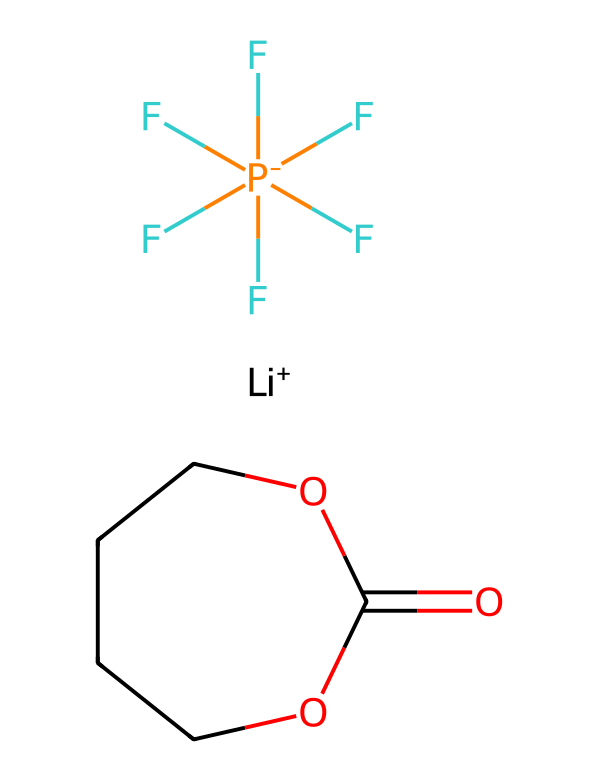What is the molecular formula of this compound? The compound consists of multiple atoms including carbon, oxygen, fluorine, and lithium. By counting the atoms in the provided SMILES representation, we find the molecular formula is C4H6F5LiO3.
Answer: C4H6F5LiO3 How many fluorine atoms are present? Looking at the fluorine section of the SMILES, there are five fluorine atoms depicted before the lithium ion.
Answer: 5 What functional groups are present? Analyzing the structure indicates that there are an ester (C1COC(=O)O) and a phosphate group (F[P-](F)(F)(F)(F)F) present in the chemical structure.
Answer: ester and phosphate What is the oxidation state of lithium in this compound? In the given SMILES, lithium is shown as a Li+ ion, indicating that its oxidation state is +1.
Answer: +1 What role does the fluoride play in this electrolyte? In this compound, the presence of multiple fluoride ions allows for the stabilization and increased conductivity of the electrolyte in a lithium-ion battery environment.
Answer: conductivity What type of compound is this? Given the presence of carbon, hydrogen, oxygen, fluorine, and lithium in the structure, this compound is classified as an organic electrolyte.
Answer: organic electrolyte How many rings are present in the structure? The SMILES indicates a cyclical structure which consists of one ring denoted by C1...C1, suggesting there is one ring in the compound.
Answer: 1 